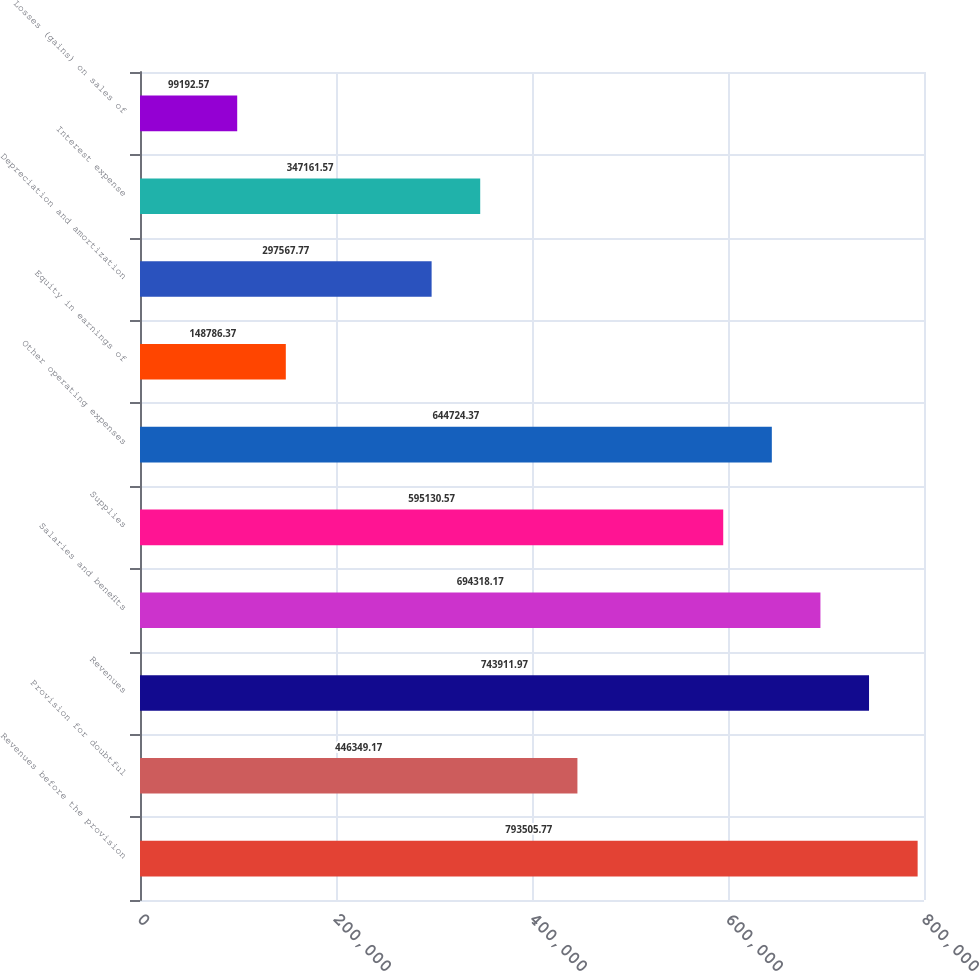Convert chart. <chart><loc_0><loc_0><loc_500><loc_500><bar_chart><fcel>Revenues before the provision<fcel>Provision for doubtful<fcel>Revenues<fcel>Salaries and benefits<fcel>Supplies<fcel>Other operating expenses<fcel>Equity in earnings of<fcel>Depreciation and amortization<fcel>Interest expense<fcel>Losses (gains) on sales of<nl><fcel>793506<fcel>446349<fcel>743912<fcel>694318<fcel>595131<fcel>644724<fcel>148786<fcel>297568<fcel>347162<fcel>99192.6<nl></chart> 